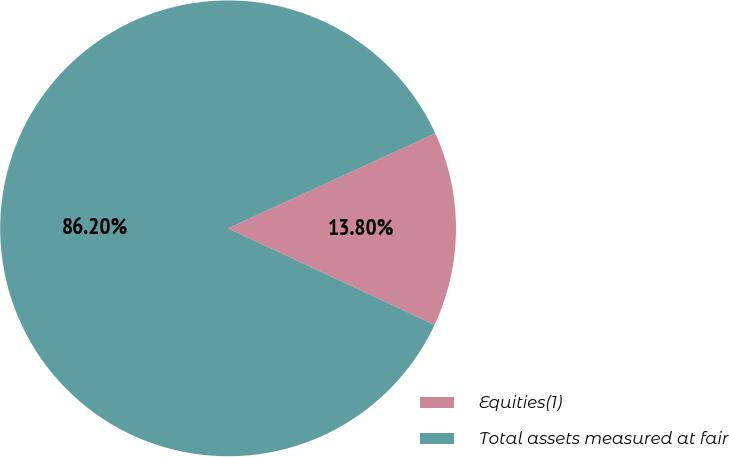Convert chart to OTSL. <chart><loc_0><loc_0><loc_500><loc_500><pie_chart><fcel>Equities(1)<fcel>Total assets measured at fair<nl><fcel>13.8%<fcel>86.2%<nl></chart> 